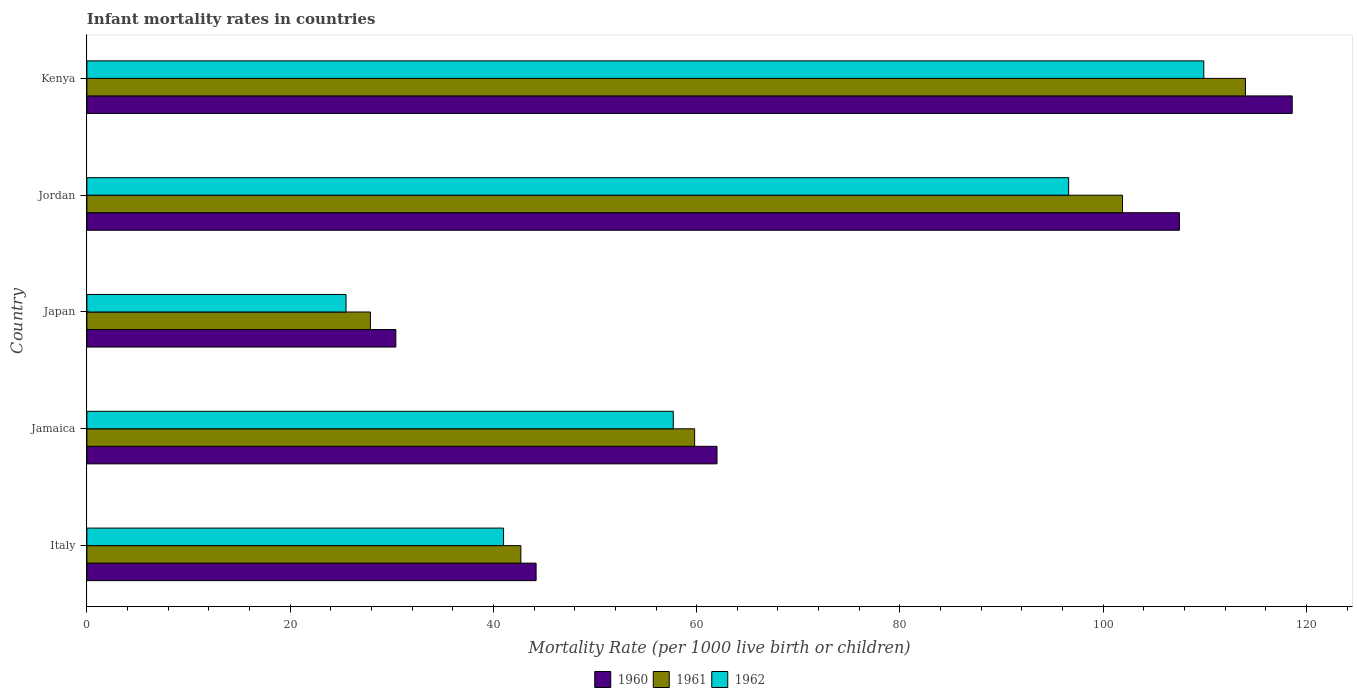How many different coloured bars are there?
Keep it short and to the point. 3. How many bars are there on the 4th tick from the top?
Offer a very short reply. 3. What is the label of the 3rd group of bars from the top?
Ensure brevity in your answer.  Japan. In how many cases, is the number of bars for a given country not equal to the number of legend labels?
Your response must be concise. 0. What is the infant mortality rate in 1961 in Kenya?
Your answer should be compact. 114. Across all countries, what is the maximum infant mortality rate in 1962?
Provide a short and direct response. 109.9. Across all countries, what is the minimum infant mortality rate in 1960?
Your answer should be very brief. 30.4. In which country was the infant mortality rate in 1962 maximum?
Make the answer very short. Kenya. What is the total infant mortality rate in 1961 in the graph?
Your response must be concise. 346.3. What is the difference between the infant mortality rate in 1962 in Jamaica and that in Kenya?
Give a very brief answer. -52.2. What is the difference between the infant mortality rate in 1961 in Jordan and the infant mortality rate in 1962 in Jamaica?
Provide a short and direct response. 44.2. What is the average infant mortality rate in 1962 per country?
Your answer should be compact. 66.14. What is the difference between the infant mortality rate in 1961 and infant mortality rate in 1962 in Jordan?
Ensure brevity in your answer.  5.3. What is the ratio of the infant mortality rate in 1960 in Jordan to that in Kenya?
Keep it short and to the point. 0.91. Is the difference between the infant mortality rate in 1961 in Japan and Kenya greater than the difference between the infant mortality rate in 1962 in Japan and Kenya?
Your answer should be very brief. No. What is the difference between the highest and the second highest infant mortality rate in 1961?
Keep it short and to the point. 12.1. What is the difference between the highest and the lowest infant mortality rate in 1961?
Offer a very short reply. 86.1. Is the sum of the infant mortality rate in 1961 in Jamaica and Jordan greater than the maximum infant mortality rate in 1962 across all countries?
Your answer should be compact. Yes. What does the 1st bar from the top in Italy represents?
Make the answer very short. 1962. What does the 1st bar from the bottom in Jamaica represents?
Your answer should be very brief. 1960. How many countries are there in the graph?
Give a very brief answer. 5. What is the difference between two consecutive major ticks on the X-axis?
Make the answer very short. 20. Does the graph contain grids?
Give a very brief answer. No. Where does the legend appear in the graph?
Offer a terse response. Bottom center. How are the legend labels stacked?
Ensure brevity in your answer.  Horizontal. What is the title of the graph?
Give a very brief answer. Infant mortality rates in countries. Does "1980" appear as one of the legend labels in the graph?
Provide a succinct answer. No. What is the label or title of the X-axis?
Provide a short and direct response. Mortality Rate (per 1000 live birth or children). What is the Mortality Rate (per 1000 live birth or children) in 1960 in Italy?
Give a very brief answer. 44.2. What is the Mortality Rate (per 1000 live birth or children) of 1961 in Italy?
Provide a succinct answer. 42.7. What is the Mortality Rate (per 1000 live birth or children) in 1961 in Jamaica?
Offer a very short reply. 59.8. What is the Mortality Rate (per 1000 live birth or children) in 1962 in Jamaica?
Give a very brief answer. 57.7. What is the Mortality Rate (per 1000 live birth or children) of 1960 in Japan?
Offer a terse response. 30.4. What is the Mortality Rate (per 1000 live birth or children) in 1961 in Japan?
Your answer should be compact. 27.9. What is the Mortality Rate (per 1000 live birth or children) in 1960 in Jordan?
Provide a short and direct response. 107.5. What is the Mortality Rate (per 1000 live birth or children) of 1961 in Jordan?
Provide a short and direct response. 101.9. What is the Mortality Rate (per 1000 live birth or children) of 1962 in Jordan?
Make the answer very short. 96.6. What is the Mortality Rate (per 1000 live birth or children) in 1960 in Kenya?
Provide a short and direct response. 118.6. What is the Mortality Rate (per 1000 live birth or children) in 1961 in Kenya?
Your response must be concise. 114. What is the Mortality Rate (per 1000 live birth or children) in 1962 in Kenya?
Offer a terse response. 109.9. Across all countries, what is the maximum Mortality Rate (per 1000 live birth or children) in 1960?
Your response must be concise. 118.6. Across all countries, what is the maximum Mortality Rate (per 1000 live birth or children) of 1961?
Your answer should be compact. 114. Across all countries, what is the maximum Mortality Rate (per 1000 live birth or children) of 1962?
Provide a short and direct response. 109.9. Across all countries, what is the minimum Mortality Rate (per 1000 live birth or children) in 1960?
Your answer should be compact. 30.4. Across all countries, what is the minimum Mortality Rate (per 1000 live birth or children) in 1961?
Your answer should be very brief. 27.9. Across all countries, what is the minimum Mortality Rate (per 1000 live birth or children) in 1962?
Provide a short and direct response. 25.5. What is the total Mortality Rate (per 1000 live birth or children) of 1960 in the graph?
Your response must be concise. 362.7. What is the total Mortality Rate (per 1000 live birth or children) of 1961 in the graph?
Your answer should be very brief. 346.3. What is the total Mortality Rate (per 1000 live birth or children) of 1962 in the graph?
Provide a short and direct response. 330.7. What is the difference between the Mortality Rate (per 1000 live birth or children) in 1960 in Italy and that in Jamaica?
Offer a very short reply. -17.8. What is the difference between the Mortality Rate (per 1000 live birth or children) in 1961 in Italy and that in Jamaica?
Provide a short and direct response. -17.1. What is the difference between the Mortality Rate (per 1000 live birth or children) of 1962 in Italy and that in Jamaica?
Give a very brief answer. -16.7. What is the difference between the Mortality Rate (per 1000 live birth or children) of 1960 in Italy and that in Japan?
Ensure brevity in your answer.  13.8. What is the difference between the Mortality Rate (per 1000 live birth or children) of 1962 in Italy and that in Japan?
Offer a very short reply. 15.5. What is the difference between the Mortality Rate (per 1000 live birth or children) in 1960 in Italy and that in Jordan?
Give a very brief answer. -63.3. What is the difference between the Mortality Rate (per 1000 live birth or children) in 1961 in Italy and that in Jordan?
Your answer should be compact. -59.2. What is the difference between the Mortality Rate (per 1000 live birth or children) in 1962 in Italy and that in Jordan?
Ensure brevity in your answer.  -55.6. What is the difference between the Mortality Rate (per 1000 live birth or children) of 1960 in Italy and that in Kenya?
Give a very brief answer. -74.4. What is the difference between the Mortality Rate (per 1000 live birth or children) of 1961 in Italy and that in Kenya?
Ensure brevity in your answer.  -71.3. What is the difference between the Mortality Rate (per 1000 live birth or children) of 1962 in Italy and that in Kenya?
Offer a terse response. -68.9. What is the difference between the Mortality Rate (per 1000 live birth or children) in 1960 in Jamaica and that in Japan?
Give a very brief answer. 31.6. What is the difference between the Mortality Rate (per 1000 live birth or children) in 1961 in Jamaica and that in Japan?
Your answer should be very brief. 31.9. What is the difference between the Mortality Rate (per 1000 live birth or children) in 1962 in Jamaica and that in Japan?
Your answer should be very brief. 32.2. What is the difference between the Mortality Rate (per 1000 live birth or children) in 1960 in Jamaica and that in Jordan?
Ensure brevity in your answer.  -45.5. What is the difference between the Mortality Rate (per 1000 live birth or children) of 1961 in Jamaica and that in Jordan?
Give a very brief answer. -42.1. What is the difference between the Mortality Rate (per 1000 live birth or children) in 1962 in Jamaica and that in Jordan?
Your response must be concise. -38.9. What is the difference between the Mortality Rate (per 1000 live birth or children) of 1960 in Jamaica and that in Kenya?
Ensure brevity in your answer.  -56.6. What is the difference between the Mortality Rate (per 1000 live birth or children) in 1961 in Jamaica and that in Kenya?
Offer a terse response. -54.2. What is the difference between the Mortality Rate (per 1000 live birth or children) of 1962 in Jamaica and that in Kenya?
Make the answer very short. -52.2. What is the difference between the Mortality Rate (per 1000 live birth or children) of 1960 in Japan and that in Jordan?
Your answer should be very brief. -77.1. What is the difference between the Mortality Rate (per 1000 live birth or children) of 1961 in Japan and that in Jordan?
Your answer should be very brief. -74. What is the difference between the Mortality Rate (per 1000 live birth or children) of 1962 in Japan and that in Jordan?
Offer a terse response. -71.1. What is the difference between the Mortality Rate (per 1000 live birth or children) in 1960 in Japan and that in Kenya?
Ensure brevity in your answer.  -88.2. What is the difference between the Mortality Rate (per 1000 live birth or children) in 1961 in Japan and that in Kenya?
Your answer should be very brief. -86.1. What is the difference between the Mortality Rate (per 1000 live birth or children) of 1962 in Japan and that in Kenya?
Keep it short and to the point. -84.4. What is the difference between the Mortality Rate (per 1000 live birth or children) of 1960 in Jordan and that in Kenya?
Your answer should be compact. -11.1. What is the difference between the Mortality Rate (per 1000 live birth or children) in 1961 in Jordan and that in Kenya?
Your answer should be very brief. -12.1. What is the difference between the Mortality Rate (per 1000 live birth or children) of 1960 in Italy and the Mortality Rate (per 1000 live birth or children) of 1961 in Jamaica?
Your response must be concise. -15.6. What is the difference between the Mortality Rate (per 1000 live birth or children) in 1960 in Italy and the Mortality Rate (per 1000 live birth or children) in 1962 in Jamaica?
Offer a terse response. -13.5. What is the difference between the Mortality Rate (per 1000 live birth or children) of 1960 in Italy and the Mortality Rate (per 1000 live birth or children) of 1961 in Japan?
Your answer should be very brief. 16.3. What is the difference between the Mortality Rate (per 1000 live birth or children) in 1960 in Italy and the Mortality Rate (per 1000 live birth or children) in 1961 in Jordan?
Offer a terse response. -57.7. What is the difference between the Mortality Rate (per 1000 live birth or children) in 1960 in Italy and the Mortality Rate (per 1000 live birth or children) in 1962 in Jordan?
Make the answer very short. -52.4. What is the difference between the Mortality Rate (per 1000 live birth or children) of 1961 in Italy and the Mortality Rate (per 1000 live birth or children) of 1962 in Jordan?
Your response must be concise. -53.9. What is the difference between the Mortality Rate (per 1000 live birth or children) in 1960 in Italy and the Mortality Rate (per 1000 live birth or children) in 1961 in Kenya?
Provide a short and direct response. -69.8. What is the difference between the Mortality Rate (per 1000 live birth or children) of 1960 in Italy and the Mortality Rate (per 1000 live birth or children) of 1962 in Kenya?
Make the answer very short. -65.7. What is the difference between the Mortality Rate (per 1000 live birth or children) of 1961 in Italy and the Mortality Rate (per 1000 live birth or children) of 1962 in Kenya?
Your answer should be very brief. -67.2. What is the difference between the Mortality Rate (per 1000 live birth or children) in 1960 in Jamaica and the Mortality Rate (per 1000 live birth or children) in 1961 in Japan?
Offer a terse response. 34.1. What is the difference between the Mortality Rate (per 1000 live birth or children) in 1960 in Jamaica and the Mortality Rate (per 1000 live birth or children) in 1962 in Japan?
Your answer should be very brief. 36.5. What is the difference between the Mortality Rate (per 1000 live birth or children) of 1961 in Jamaica and the Mortality Rate (per 1000 live birth or children) of 1962 in Japan?
Provide a succinct answer. 34.3. What is the difference between the Mortality Rate (per 1000 live birth or children) of 1960 in Jamaica and the Mortality Rate (per 1000 live birth or children) of 1961 in Jordan?
Provide a short and direct response. -39.9. What is the difference between the Mortality Rate (per 1000 live birth or children) in 1960 in Jamaica and the Mortality Rate (per 1000 live birth or children) in 1962 in Jordan?
Offer a very short reply. -34.6. What is the difference between the Mortality Rate (per 1000 live birth or children) of 1961 in Jamaica and the Mortality Rate (per 1000 live birth or children) of 1962 in Jordan?
Provide a succinct answer. -36.8. What is the difference between the Mortality Rate (per 1000 live birth or children) in 1960 in Jamaica and the Mortality Rate (per 1000 live birth or children) in 1961 in Kenya?
Keep it short and to the point. -52. What is the difference between the Mortality Rate (per 1000 live birth or children) in 1960 in Jamaica and the Mortality Rate (per 1000 live birth or children) in 1962 in Kenya?
Keep it short and to the point. -47.9. What is the difference between the Mortality Rate (per 1000 live birth or children) in 1961 in Jamaica and the Mortality Rate (per 1000 live birth or children) in 1962 in Kenya?
Your response must be concise. -50.1. What is the difference between the Mortality Rate (per 1000 live birth or children) in 1960 in Japan and the Mortality Rate (per 1000 live birth or children) in 1961 in Jordan?
Provide a short and direct response. -71.5. What is the difference between the Mortality Rate (per 1000 live birth or children) in 1960 in Japan and the Mortality Rate (per 1000 live birth or children) in 1962 in Jordan?
Your answer should be very brief. -66.2. What is the difference between the Mortality Rate (per 1000 live birth or children) of 1961 in Japan and the Mortality Rate (per 1000 live birth or children) of 1962 in Jordan?
Offer a very short reply. -68.7. What is the difference between the Mortality Rate (per 1000 live birth or children) in 1960 in Japan and the Mortality Rate (per 1000 live birth or children) in 1961 in Kenya?
Your answer should be compact. -83.6. What is the difference between the Mortality Rate (per 1000 live birth or children) in 1960 in Japan and the Mortality Rate (per 1000 live birth or children) in 1962 in Kenya?
Provide a succinct answer. -79.5. What is the difference between the Mortality Rate (per 1000 live birth or children) of 1961 in Japan and the Mortality Rate (per 1000 live birth or children) of 1962 in Kenya?
Provide a short and direct response. -82. What is the difference between the Mortality Rate (per 1000 live birth or children) in 1960 in Jordan and the Mortality Rate (per 1000 live birth or children) in 1961 in Kenya?
Your answer should be compact. -6.5. What is the average Mortality Rate (per 1000 live birth or children) of 1960 per country?
Your response must be concise. 72.54. What is the average Mortality Rate (per 1000 live birth or children) in 1961 per country?
Offer a very short reply. 69.26. What is the average Mortality Rate (per 1000 live birth or children) of 1962 per country?
Your answer should be compact. 66.14. What is the difference between the Mortality Rate (per 1000 live birth or children) in 1960 and Mortality Rate (per 1000 live birth or children) in 1962 in Italy?
Your answer should be very brief. 3.2. What is the difference between the Mortality Rate (per 1000 live birth or children) in 1961 and Mortality Rate (per 1000 live birth or children) in 1962 in Italy?
Provide a succinct answer. 1.7. What is the difference between the Mortality Rate (per 1000 live birth or children) of 1960 and Mortality Rate (per 1000 live birth or children) of 1962 in Jamaica?
Offer a very short reply. 4.3. What is the difference between the Mortality Rate (per 1000 live birth or children) in 1961 and Mortality Rate (per 1000 live birth or children) in 1962 in Jamaica?
Provide a succinct answer. 2.1. What is the difference between the Mortality Rate (per 1000 live birth or children) in 1960 and Mortality Rate (per 1000 live birth or children) in 1962 in Japan?
Your answer should be compact. 4.9. What is the difference between the Mortality Rate (per 1000 live birth or children) in 1961 and Mortality Rate (per 1000 live birth or children) in 1962 in Japan?
Offer a very short reply. 2.4. What is the difference between the Mortality Rate (per 1000 live birth or children) in 1960 and Mortality Rate (per 1000 live birth or children) in 1961 in Jordan?
Give a very brief answer. 5.6. What is the difference between the Mortality Rate (per 1000 live birth or children) of 1960 and Mortality Rate (per 1000 live birth or children) of 1961 in Kenya?
Ensure brevity in your answer.  4.6. What is the difference between the Mortality Rate (per 1000 live birth or children) in 1961 and Mortality Rate (per 1000 live birth or children) in 1962 in Kenya?
Give a very brief answer. 4.1. What is the ratio of the Mortality Rate (per 1000 live birth or children) of 1960 in Italy to that in Jamaica?
Provide a short and direct response. 0.71. What is the ratio of the Mortality Rate (per 1000 live birth or children) in 1961 in Italy to that in Jamaica?
Your response must be concise. 0.71. What is the ratio of the Mortality Rate (per 1000 live birth or children) of 1962 in Italy to that in Jamaica?
Ensure brevity in your answer.  0.71. What is the ratio of the Mortality Rate (per 1000 live birth or children) in 1960 in Italy to that in Japan?
Make the answer very short. 1.45. What is the ratio of the Mortality Rate (per 1000 live birth or children) in 1961 in Italy to that in Japan?
Make the answer very short. 1.53. What is the ratio of the Mortality Rate (per 1000 live birth or children) in 1962 in Italy to that in Japan?
Your answer should be very brief. 1.61. What is the ratio of the Mortality Rate (per 1000 live birth or children) of 1960 in Italy to that in Jordan?
Ensure brevity in your answer.  0.41. What is the ratio of the Mortality Rate (per 1000 live birth or children) in 1961 in Italy to that in Jordan?
Your answer should be compact. 0.42. What is the ratio of the Mortality Rate (per 1000 live birth or children) in 1962 in Italy to that in Jordan?
Your answer should be compact. 0.42. What is the ratio of the Mortality Rate (per 1000 live birth or children) of 1960 in Italy to that in Kenya?
Your answer should be very brief. 0.37. What is the ratio of the Mortality Rate (per 1000 live birth or children) in 1961 in Italy to that in Kenya?
Ensure brevity in your answer.  0.37. What is the ratio of the Mortality Rate (per 1000 live birth or children) of 1962 in Italy to that in Kenya?
Offer a very short reply. 0.37. What is the ratio of the Mortality Rate (per 1000 live birth or children) of 1960 in Jamaica to that in Japan?
Your answer should be very brief. 2.04. What is the ratio of the Mortality Rate (per 1000 live birth or children) in 1961 in Jamaica to that in Japan?
Your response must be concise. 2.14. What is the ratio of the Mortality Rate (per 1000 live birth or children) in 1962 in Jamaica to that in Japan?
Provide a short and direct response. 2.26. What is the ratio of the Mortality Rate (per 1000 live birth or children) of 1960 in Jamaica to that in Jordan?
Your response must be concise. 0.58. What is the ratio of the Mortality Rate (per 1000 live birth or children) of 1961 in Jamaica to that in Jordan?
Offer a terse response. 0.59. What is the ratio of the Mortality Rate (per 1000 live birth or children) of 1962 in Jamaica to that in Jordan?
Your response must be concise. 0.6. What is the ratio of the Mortality Rate (per 1000 live birth or children) of 1960 in Jamaica to that in Kenya?
Your answer should be compact. 0.52. What is the ratio of the Mortality Rate (per 1000 live birth or children) of 1961 in Jamaica to that in Kenya?
Your answer should be very brief. 0.52. What is the ratio of the Mortality Rate (per 1000 live birth or children) of 1962 in Jamaica to that in Kenya?
Keep it short and to the point. 0.53. What is the ratio of the Mortality Rate (per 1000 live birth or children) of 1960 in Japan to that in Jordan?
Your answer should be very brief. 0.28. What is the ratio of the Mortality Rate (per 1000 live birth or children) of 1961 in Japan to that in Jordan?
Your answer should be very brief. 0.27. What is the ratio of the Mortality Rate (per 1000 live birth or children) in 1962 in Japan to that in Jordan?
Keep it short and to the point. 0.26. What is the ratio of the Mortality Rate (per 1000 live birth or children) of 1960 in Japan to that in Kenya?
Your answer should be compact. 0.26. What is the ratio of the Mortality Rate (per 1000 live birth or children) in 1961 in Japan to that in Kenya?
Provide a succinct answer. 0.24. What is the ratio of the Mortality Rate (per 1000 live birth or children) of 1962 in Japan to that in Kenya?
Give a very brief answer. 0.23. What is the ratio of the Mortality Rate (per 1000 live birth or children) in 1960 in Jordan to that in Kenya?
Your answer should be very brief. 0.91. What is the ratio of the Mortality Rate (per 1000 live birth or children) in 1961 in Jordan to that in Kenya?
Your response must be concise. 0.89. What is the ratio of the Mortality Rate (per 1000 live birth or children) in 1962 in Jordan to that in Kenya?
Ensure brevity in your answer.  0.88. What is the difference between the highest and the second highest Mortality Rate (per 1000 live birth or children) of 1960?
Offer a very short reply. 11.1. What is the difference between the highest and the second highest Mortality Rate (per 1000 live birth or children) of 1961?
Provide a short and direct response. 12.1. What is the difference between the highest and the lowest Mortality Rate (per 1000 live birth or children) of 1960?
Offer a terse response. 88.2. What is the difference between the highest and the lowest Mortality Rate (per 1000 live birth or children) of 1961?
Your answer should be compact. 86.1. What is the difference between the highest and the lowest Mortality Rate (per 1000 live birth or children) in 1962?
Your response must be concise. 84.4. 